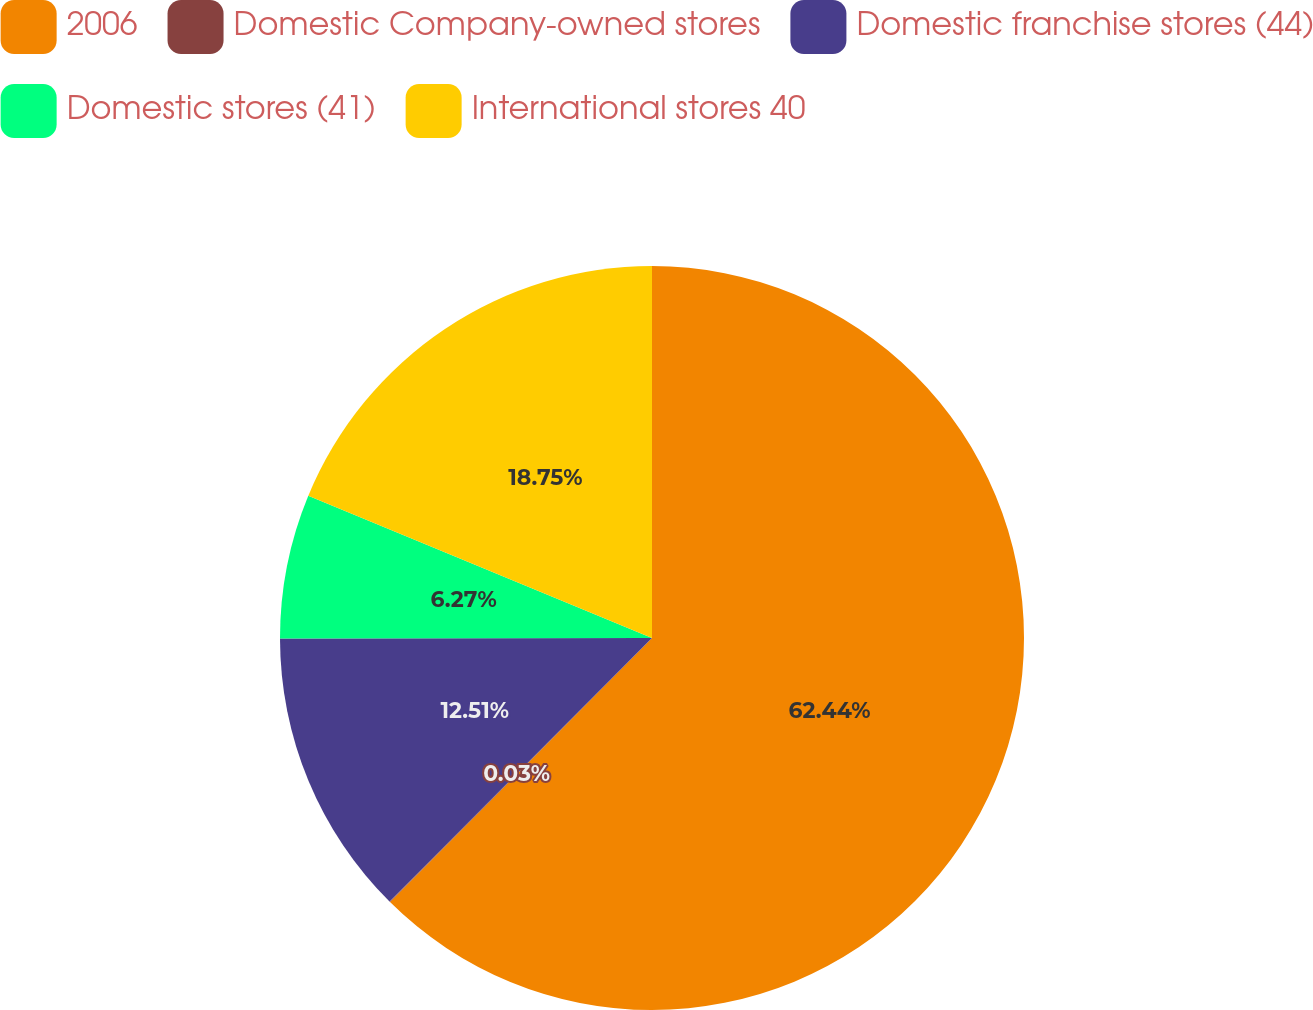<chart> <loc_0><loc_0><loc_500><loc_500><pie_chart><fcel>2006<fcel>Domestic Company-owned stores<fcel>Domestic franchise stores (44)<fcel>Domestic stores (41)<fcel>International stores 40<nl><fcel>62.43%<fcel>0.03%<fcel>12.51%<fcel>6.27%<fcel>18.75%<nl></chart> 